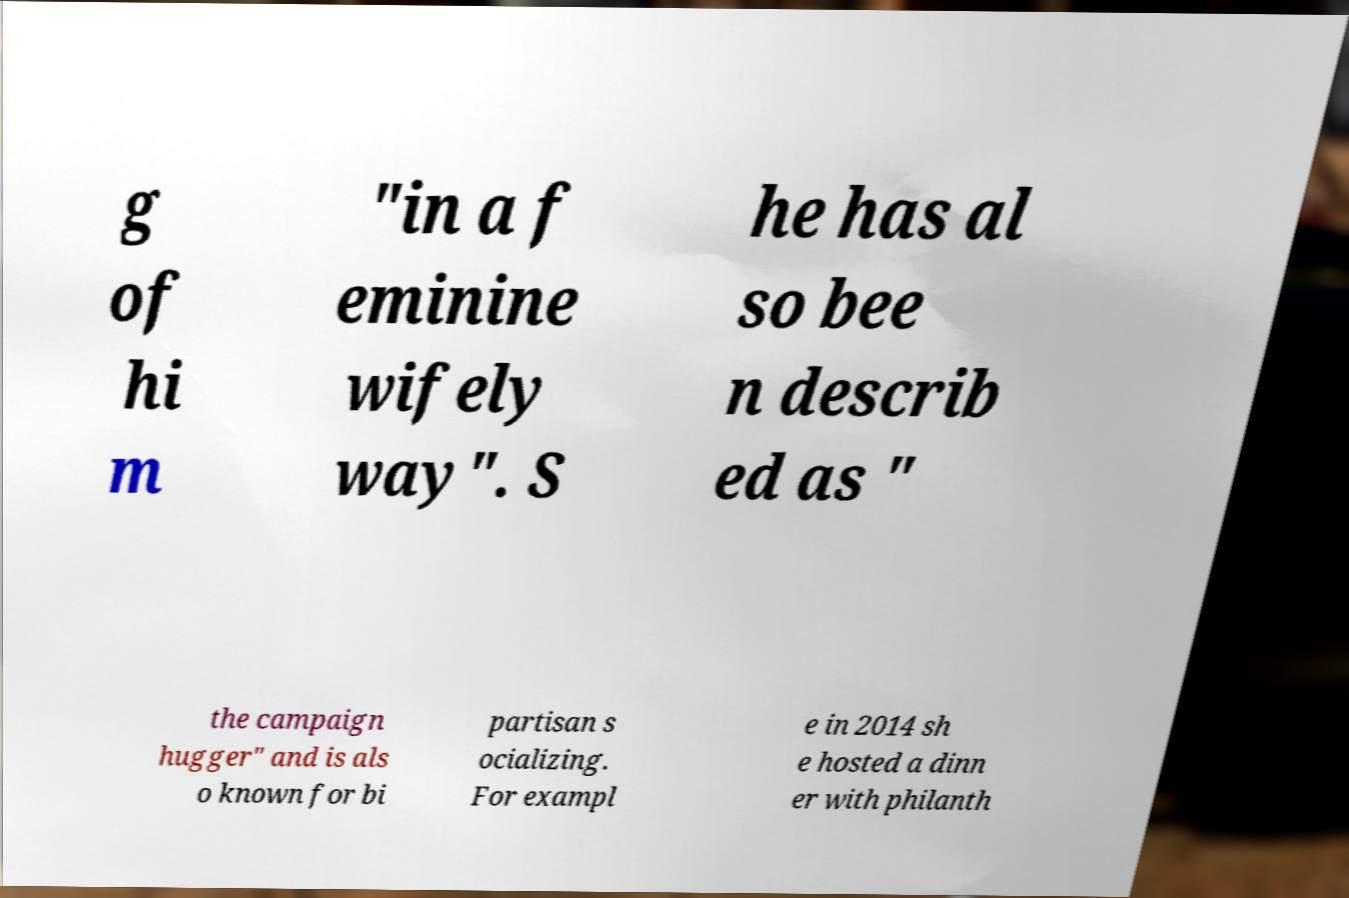For documentation purposes, I need the text within this image transcribed. Could you provide that? g of hi m "in a f eminine wifely way". S he has al so bee n describ ed as " the campaign hugger" and is als o known for bi partisan s ocializing. For exampl e in 2014 sh e hosted a dinn er with philanth 